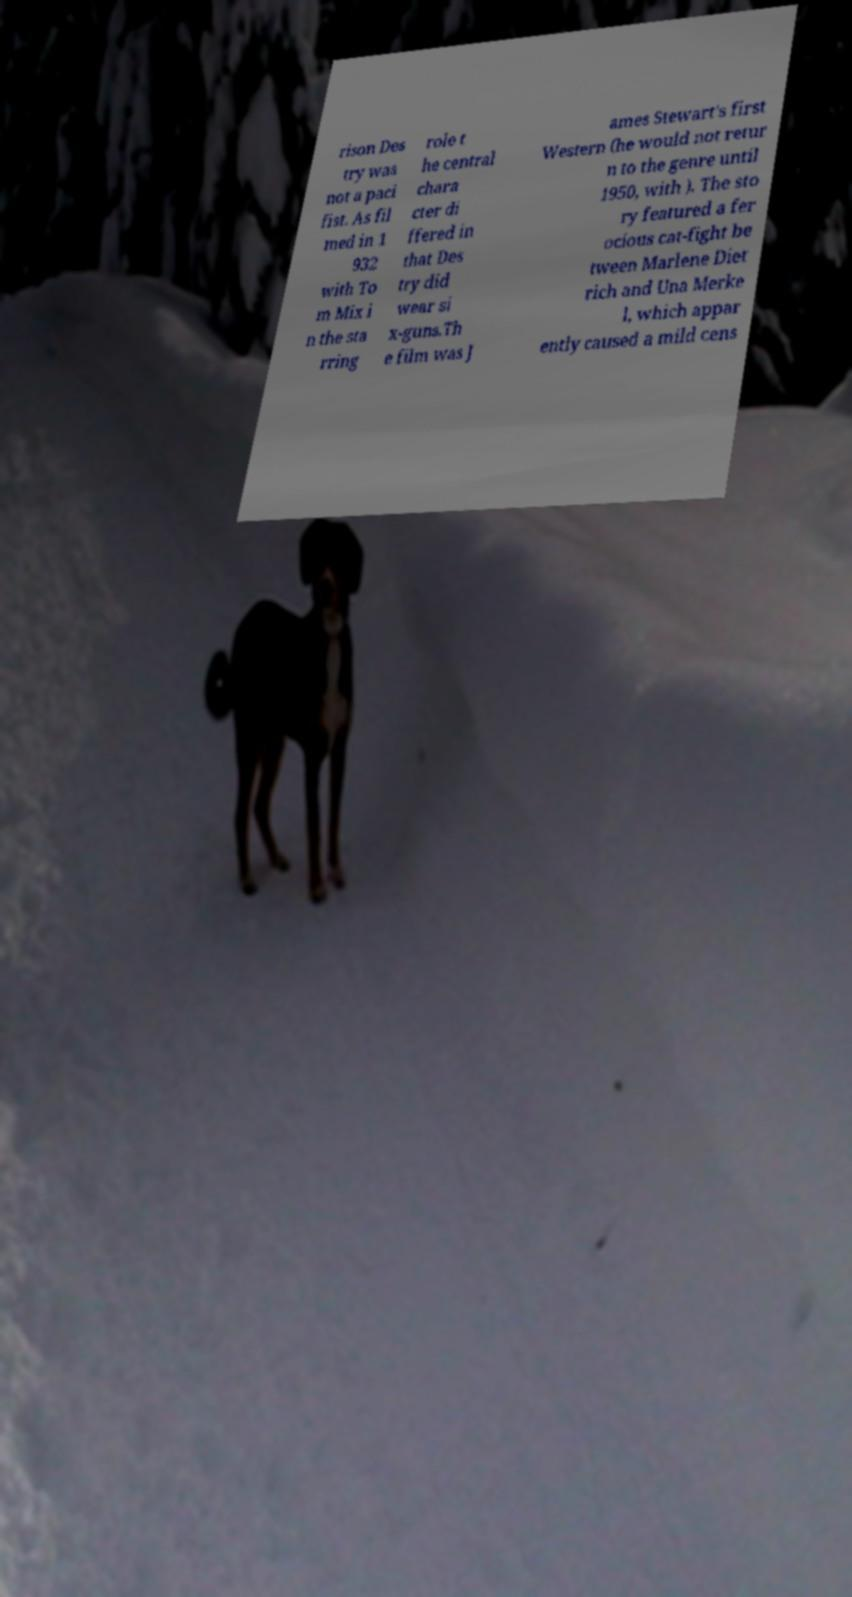I need the written content from this picture converted into text. Can you do that? rison Des try was not a paci fist. As fil med in 1 932 with To m Mix i n the sta rring role t he central chara cter di ffered in that Des try did wear si x-guns.Th e film was J ames Stewart's first Western (he would not retur n to the genre until 1950, with ). The sto ry featured a fer ocious cat-fight be tween Marlene Diet rich and Una Merke l, which appar ently caused a mild cens 